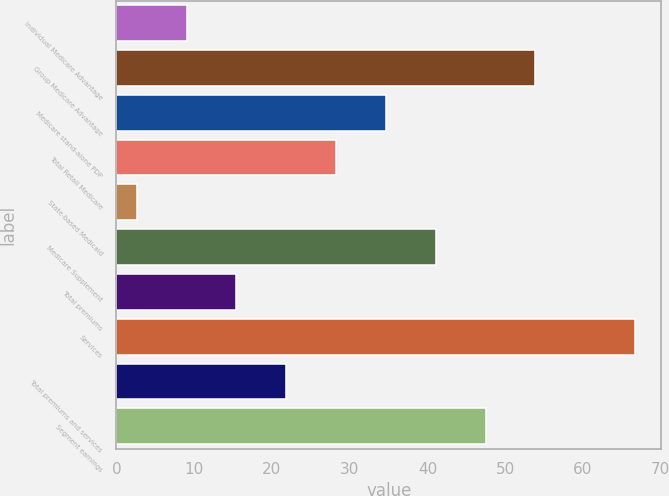Convert chart to OTSL. <chart><loc_0><loc_0><loc_500><loc_500><bar_chart><fcel>Individual Medicare Advantage<fcel>Group Medicare Advantage<fcel>Medicare stand-alone PDP<fcel>Total Retail Medicare<fcel>State-based Medicaid<fcel>Medicare Supplement<fcel>Total premiums<fcel>Services<fcel>Total premiums and services<fcel>Segment earnings<nl><fcel>9.01<fcel>53.88<fcel>34.65<fcel>28.24<fcel>2.6<fcel>41.06<fcel>15.42<fcel>66.7<fcel>21.83<fcel>47.47<nl></chart> 